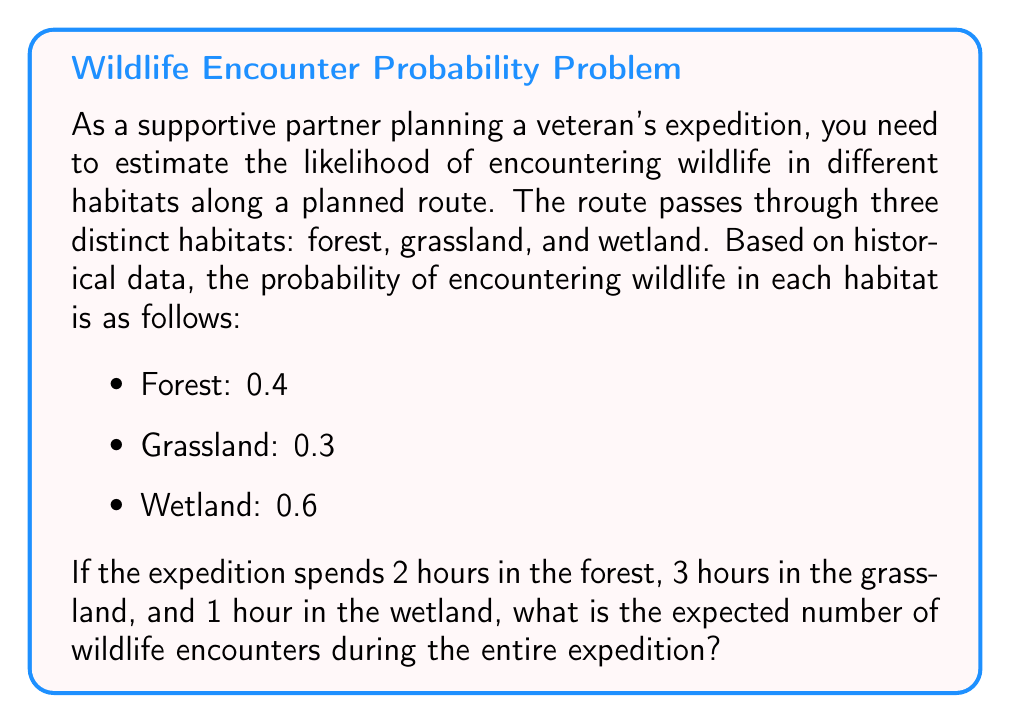What is the answer to this math problem? To solve this problem, we need to use the concept of expected value for random variables. Let's break it down step-by-step:

1. Define the random variable:
   Let $X$ be the number of wildlife encounters during the expedition.

2. Calculate the probability of encountering wildlife for each hour spent in each habitat:
   - Forest: $P(\text{encounter in forest}) = 0.4$ per hour
   - Grassland: $P(\text{encounter in grassland}) = 0.3$ per hour
   - Wetland: $P(\text{encounter in wetland}) = 0.6$ per hour

3. Calculate the expected number of encounters for each habitat:
   - Forest: $E(X_{\text{forest}}) = 2 \text{ hours} \times 0.4 = 0.8$
   - Grassland: $E(X_{\text{grassland}}) = 3 \text{ hours} \times 0.3 = 0.9$
   - Wetland: $E(X_{\text{wetland}}) = 1 \text{ hour} \times 0.6 = 0.6$

4. Calculate the total expected number of encounters:
   $$E(X) = E(X_{\text{forest}}) + E(X_{\text{grassland}}) + E(X_{\text{wetland}})$$
   $$E(X) = 0.8 + 0.9 + 0.6 = 2.3$$

Therefore, the expected number of wildlife encounters during the entire expedition is 2.3.
Answer: The expected number of wildlife encounters during the entire expedition is 2.3. 